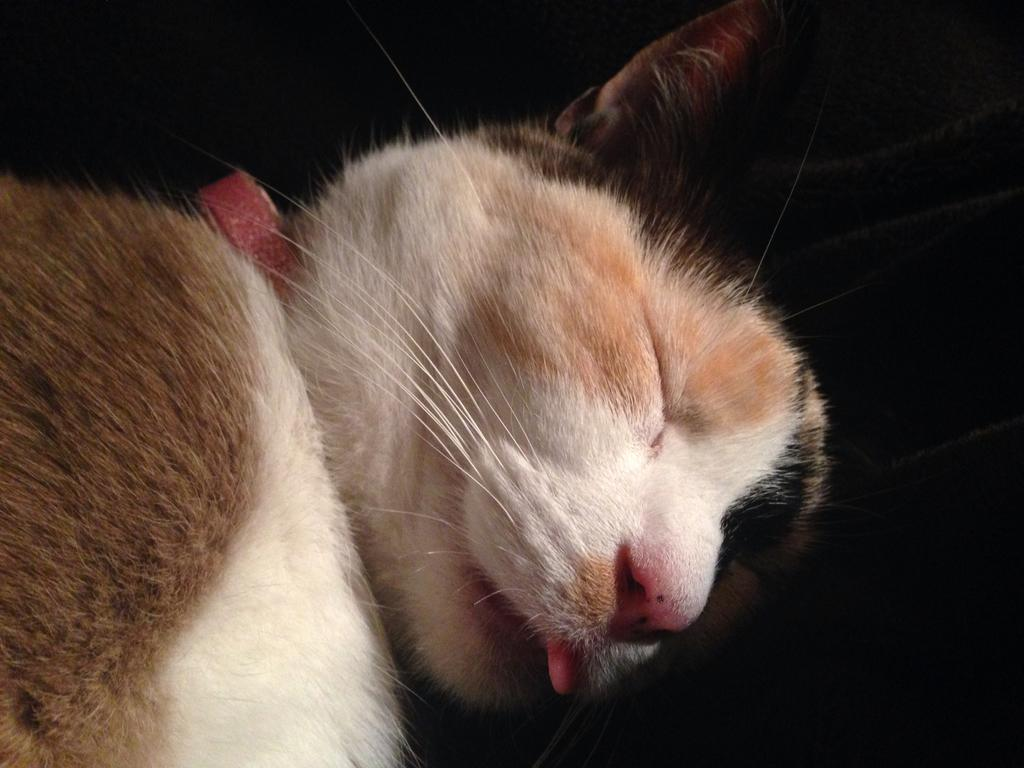What type of animal is in the image? There is a cat in the image. What is the cat doing in the image? The cat is sleeping. What type of stick is the cat using to learn in the image? There is no stick or learning activity present in the image; the cat is simply sleeping. 